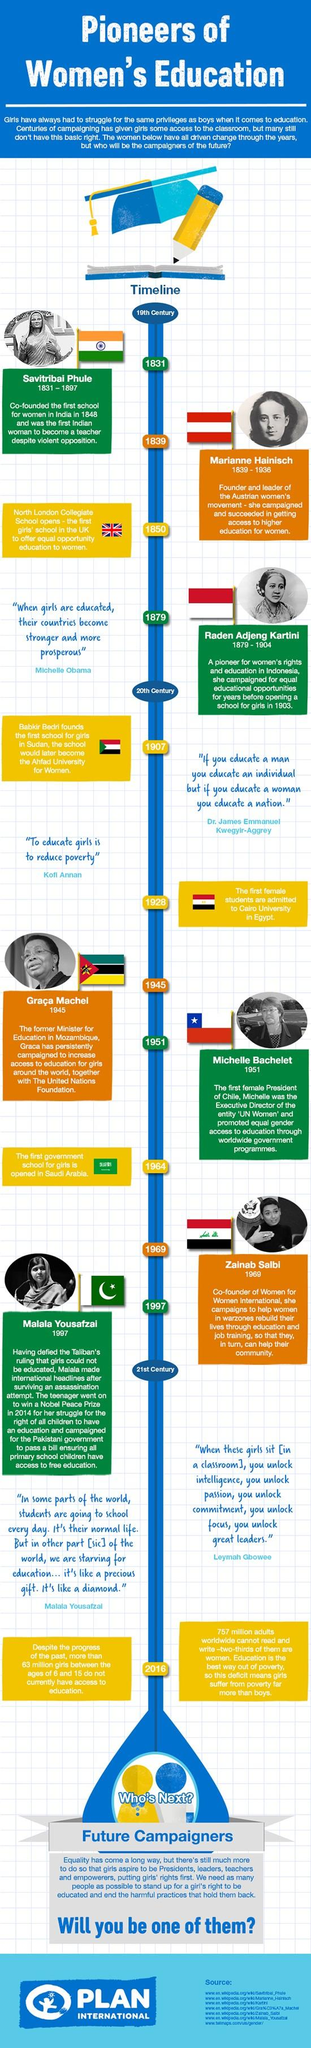Give some essential details in this illustration. In 1964, the first school for girls was opened in Saudi Arabia, marking a significant milestone in the advancement of women's education in the country. Michelle Obama asserts that when girls are educated, countries become stronger and more prosperous. The first school in Sudan was established in 1907. Zainab Salbi is the co-founder of Women for Women International. Savitribai Phule was older than Marianne by 8 years. 